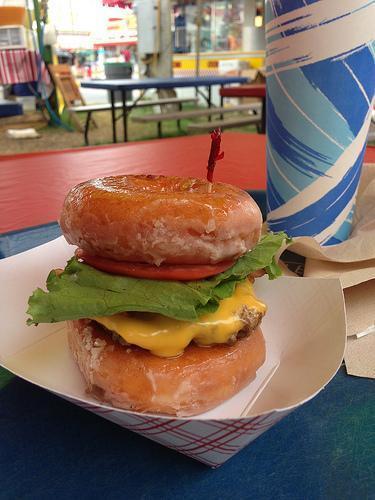How many doughnuts are there?
Give a very brief answer. 2. 